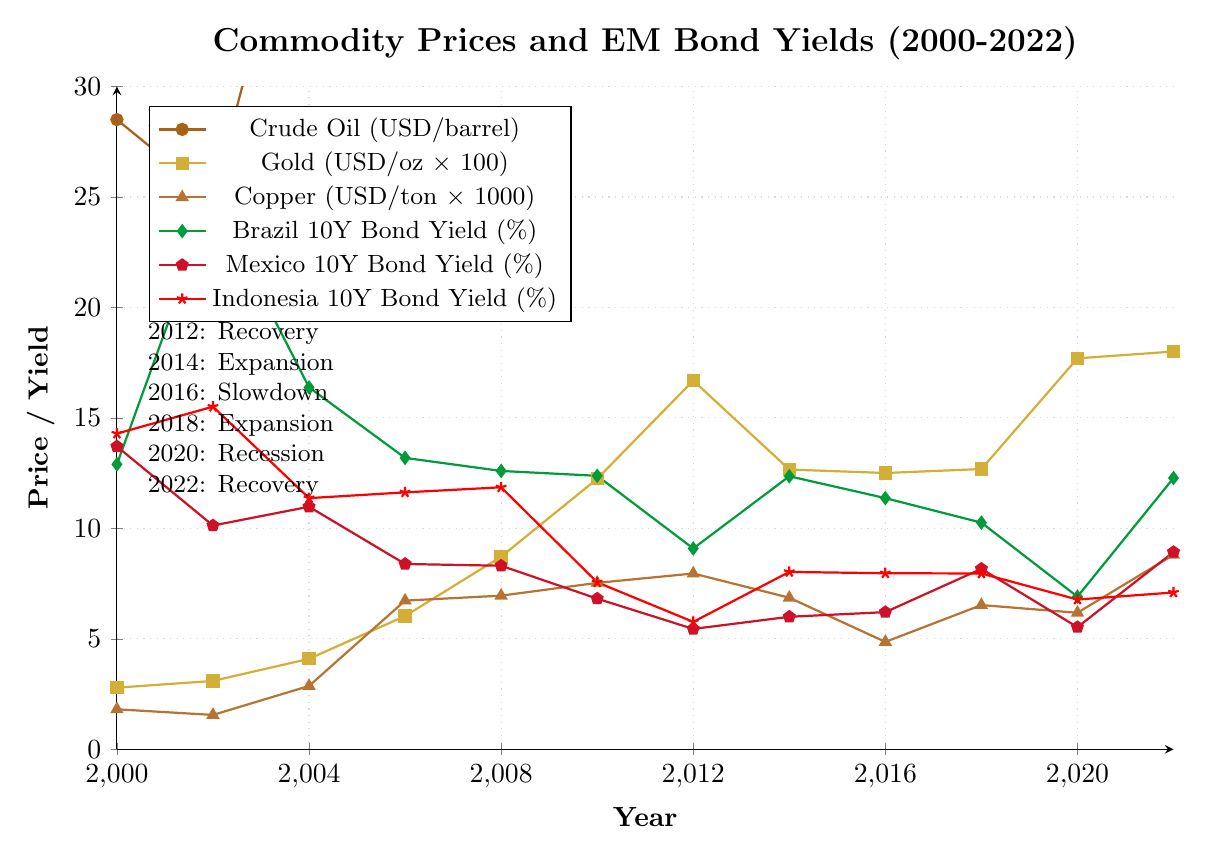What is the trend of the Brazilian 10Y bond yield throughout the dataset? The Brazilian 10Y bond yield starts at 12.90% in 2000, peaks at 24.91% in 2002, drops to lows of 9.09% in 2012, and then fluctuates in the range of about 10-12% until it reaches 12.28% in 2022. This indicates an overall downward trend with fluctuations.
Answer: Downward with fluctuations Which commodity price has the highest value in 2022, and what is that value? To identify the highest value, compare the 2022 values for Crude Oil (94.53 USD/barrel), Gold (1800.39 USD/oz), and Copper (8804.24 USD/ton). Commodity prices should be standardized by considering the units. Copper, given in thousands, has the highest effective value.
Answer: Copper, 8804.24 USD/ton How do the bond yields of Mexico and Indonesia compare in 2020? According to the data, in 2020, Mexico's 10Y bond yield is 5.53% and Indonesia's 10Y bond yield is 6.78%. Side-by-side, Indonesia's bond yield is higher than Mexico's.
Answer: Indonesia is higher During which economic cycle did the Crude Oil and Copper prices both exceed their initial values in 2000? For Crude Oil and Copper prices to both exceed their 2000 values (28.50 USD/barrel and 1813.48 USD/ton respectively), look at the chart. In 2006 (Expansion phase), both exceed these values as Crude Oil is at 66.05 USD/barrel, and Copper is at 6731.45 USD/ton.
Answer: Expansion (2006) What is the average yield for Brazil's 10Y bond over the given period? Sum Brazil’s 10Y bond yields: 12.90 + 24.91 + 16.38 + 13.19 + 12.60 + 12.38 + 9.09 + 12.36 + 11.37 + 10.26 + 6.91 + 12.28 = 154.63. There are 12 data points, so 154.63 / 12 = 12.89%.
Answer: 12.89% During which year did the difference between the highest and lowest 10Y bond yields (among Brazil, Mexico, and Indonesia) reach its peak? To find this, calculate the differences for each year and compare them. The highest difference appears in 2002 with Brazil at 24.91%, Mexico at 10.13%, and Indonesia at 15.51%. The difference is 24.91 - 10.13 = 14.78%.
Answer: 2002 How was the Copper price in 2016 compared to the other commodity prices in the same year? In 2016, Copper (4862.89 USD/ton) is compared to Crude Oil (43.29 USD/barrel) and Gold (1250.74 USD/oz). Normally standardizing the units, Copper prices are comparatively lower than its past prices but higher in absolute value in terms compared to the other commodities.
Answer: Comparatively lower What is the visual representation (color/marker) for the Indonesia 10Y bond yield, and how would you describe its overall trend? The Indonesia 10Y bond yield is represented by a star marker and red color. Its trend starts high in 2000 (14.29%), reaching a peak in 2002 (15.51%), and gradually declines to a lower range of about 6-8% in recent years with minor fluctuations.
Answer: Red star, downward trend 